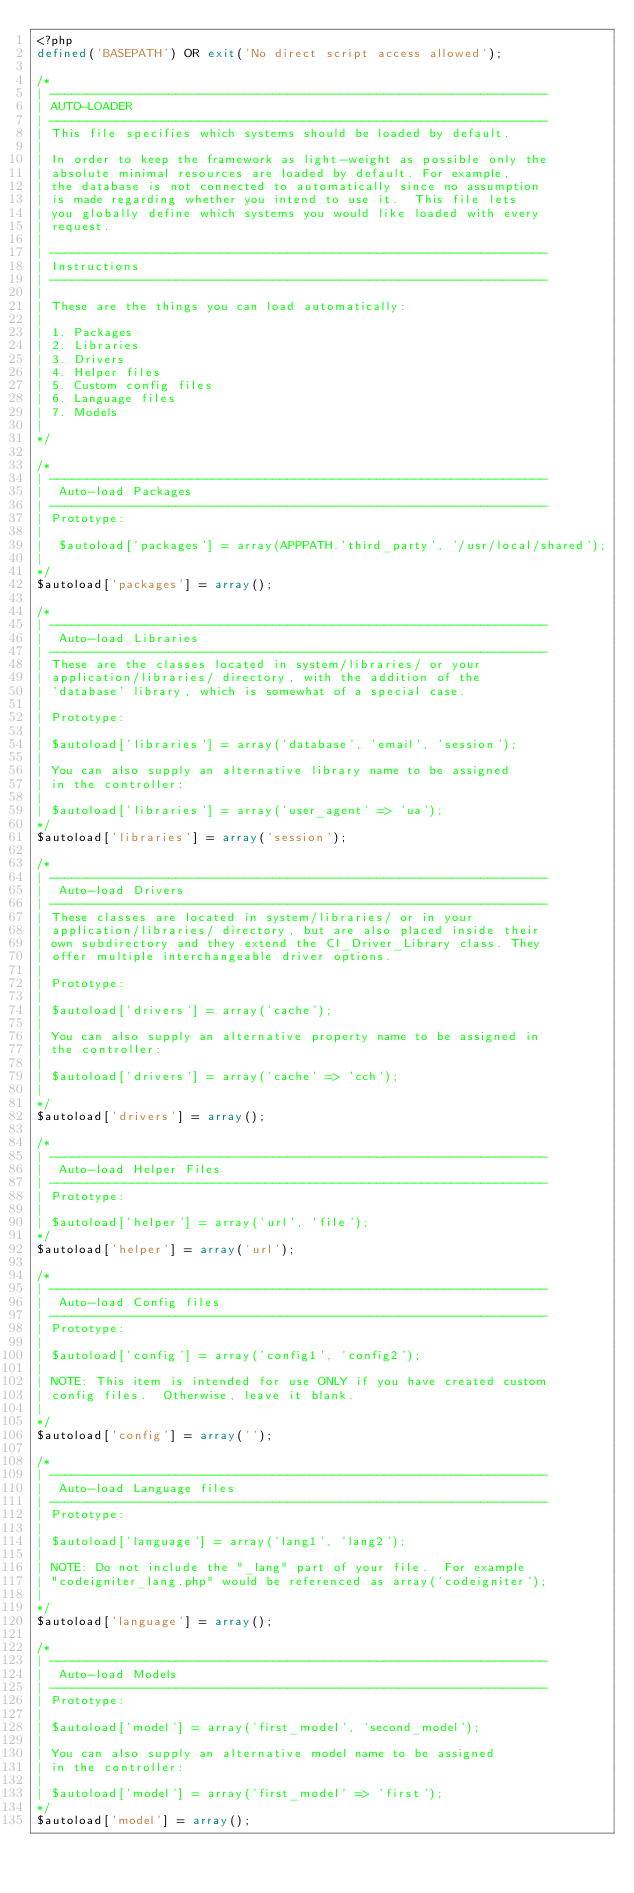Convert code to text. <code><loc_0><loc_0><loc_500><loc_500><_PHP_><?php
defined('BASEPATH') OR exit('No direct script access allowed');

/*
| -------------------------------------------------------------------
| AUTO-LOADER
| -------------------------------------------------------------------
| This file specifies which systems should be loaded by default.
|
| In order to keep the framework as light-weight as possible only the
| absolute minimal resources are loaded by default. For example,
| the database is not connected to automatically since no assumption
| is made regarding whether you intend to use it.  This file lets
| you globally define which systems you would like loaded with every
| request.
|
| -------------------------------------------------------------------
| Instructions
| -------------------------------------------------------------------
|
| These are the things you can load automatically:
|
| 1. Packages
| 2. Libraries
| 3. Drivers
| 4. Helper files
| 5. Custom config files
| 6. Language files
| 7. Models
|
*/

/*
| -------------------------------------------------------------------
|  Auto-load Packages
| -------------------------------------------------------------------
| Prototype:
|
|  $autoload['packages'] = array(APPPATH.'third_party', '/usr/local/shared');
|
*/
$autoload['packages'] = array();

/*
| -------------------------------------------------------------------
|  Auto-load Libraries
| -------------------------------------------------------------------
| These are the classes located in system/libraries/ or your
| application/libraries/ directory, with the addition of the
| 'database' library, which is somewhat of a special case.
|
| Prototype:
|
|	$autoload['libraries'] = array('database', 'email', 'session');
|
| You can also supply an alternative library name to be assigned
| in the controller:
|
|	$autoload['libraries'] = array('user_agent' => 'ua');
*/
$autoload['libraries'] = array('session');

/*
| -------------------------------------------------------------------
|  Auto-load Drivers
| -------------------------------------------------------------------
| These classes are located in system/libraries/ or in your
| application/libraries/ directory, but are also placed inside their
| own subdirectory and they extend the CI_Driver_Library class. They
| offer multiple interchangeable driver options.
|
| Prototype:
|
|	$autoload['drivers'] = array('cache');
|
| You can also supply an alternative property name to be assigned in
| the controller:
|
|	$autoload['drivers'] = array('cache' => 'cch');
|
*/
$autoload['drivers'] = array();

/*
| -------------------------------------------------------------------
|  Auto-load Helper Files
| -------------------------------------------------------------------
| Prototype:
|
|	$autoload['helper'] = array('url', 'file');
*/
$autoload['helper'] = array('url');

/*
| -------------------------------------------------------------------
|  Auto-load Config files
| -------------------------------------------------------------------
| Prototype:
|
|	$autoload['config'] = array('config1', 'config2');
|
| NOTE: This item is intended for use ONLY if you have created custom
| config files.  Otherwise, leave it blank.
|
*/
$autoload['config'] = array('');

/*
| -------------------------------------------------------------------
|  Auto-load Language files
| -------------------------------------------------------------------
| Prototype:
|
|	$autoload['language'] = array('lang1', 'lang2');
|
| NOTE: Do not include the "_lang" part of your file.  For example
| "codeigniter_lang.php" would be referenced as array('codeigniter');
|
*/
$autoload['language'] = array();

/*
| -------------------------------------------------------------------
|  Auto-load Models
| -------------------------------------------------------------------
| Prototype:
|
|	$autoload['model'] = array('first_model', 'second_model');
|
| You can also supply an alternative model name to be assigned
| in the controller:
|
|	$autoload['model'] = array('first_model' => 'first');
*/
$autoload['model'] = array();
</code> 